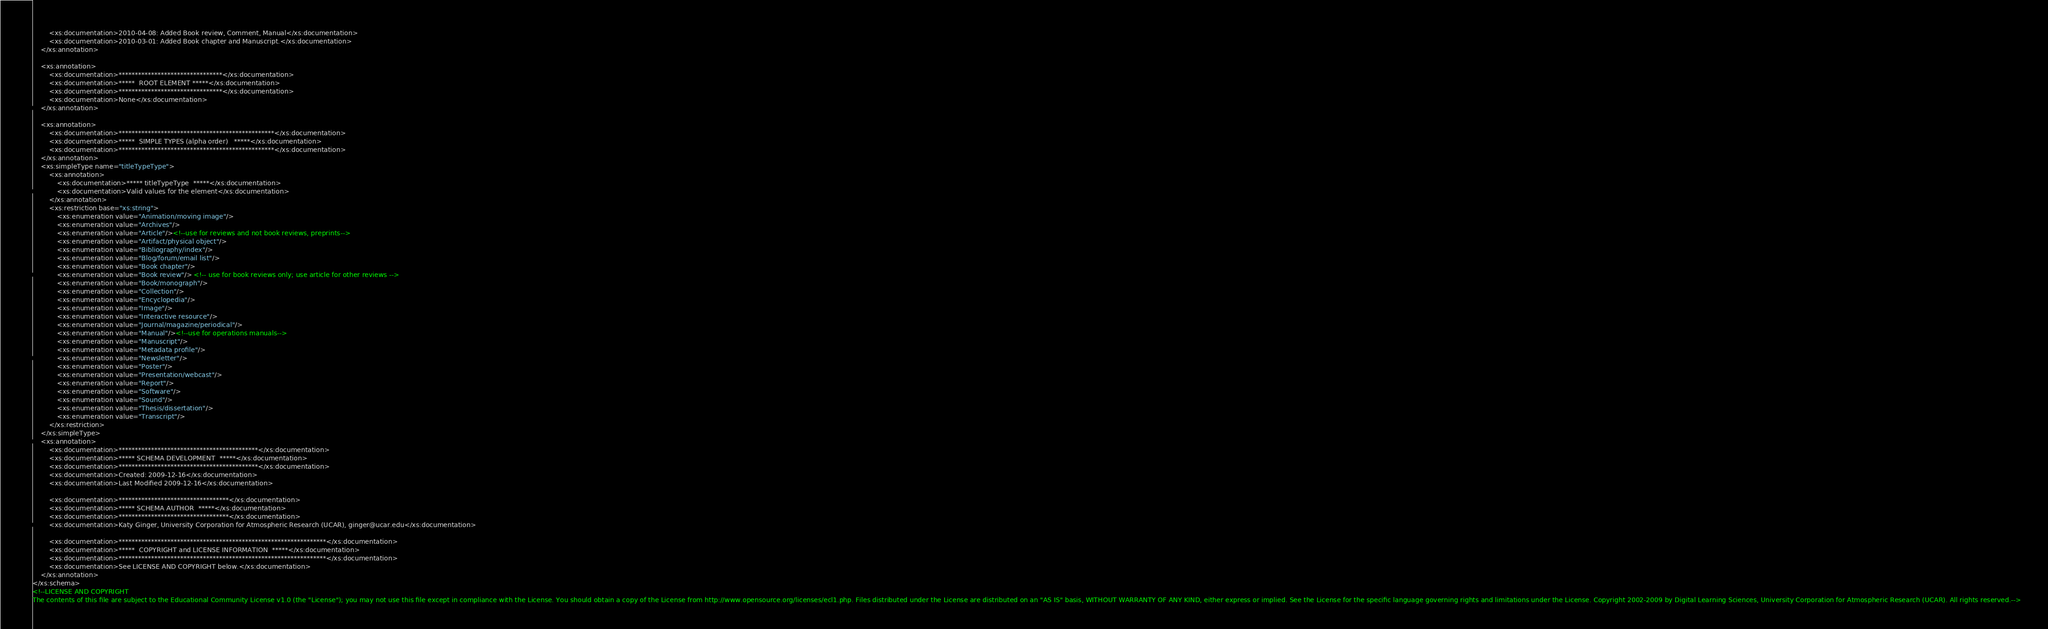Convert code to text. <code><loc_0><loc_0><loc_500><loc_500><_XML_>		<xs:documentation>2010-04-08: Added Book review, Comment, Manual</xs:documentation>
		<xs:documentation>2010-03-01: Added Book chapter and Manuscript.</xs:documentation>
	</xs:annotation>

	<xs:annotation>
		<xs:documentation>********************************</xs:documentation>
		<xs:documentation>*****  ROOT ELEMENT *****</xs:documentation>
		<xs:documentation>********************************</xs:documentation>
		<xs:documentation>None</xs:documentation>
	</xs:annotation>

	<xs:annotation>
		<xs:documentation>************************************************</xs:documentation>
		<xs:documentation>*****  SIMPLE TYPES (alpha order)   *****</xs:documentation>
		<xs:documentation>************************************************</xs:documentation>
	</xs:annotation>
	<xs:simpleType name="titleTypeType">
		<xs:annotation>
			<xs:documentation>***** titleTypeType  *****</xs:documentation>
			<xs:documentation>Valid values for the element</xs:documentation>
		</xs:annotation>
		<xs:restriction base="xs:string">
			<xs:enumeration value="Animation/moving image"/>
			<xs:enumeration value="Archives"/>
			<xs:enumeration value="Article"/><!--use for reviews and not book reviews, preprints-->
			<xs:enumeration value="Artifact/physical object"/>
			<xs:enumeration value="Bibliography/index"/>
			<xs:enumeration value="Blog/forum/email list"/>
			<xs:enumeration value="Book chapter"/>
			<xs:enumeration value="Book review"/> <!-- use for book reviews only; use article for other reviews -->
			<xs:enumeration value="Book/monograph"/>
			<xs:enumeration value="Collection"/>
			<xs:enumeration value="Encyclopedia"/>
			<xs:enumeration value="Image"/>
			<xs:enumeration value="Interactive resource"/>
			<xs:enumeration value="Journal/magazine/periodical"/>
			<xs:enumeration value="Manual"/><!--use for operations manuals-->
			<xs:enumeration value="Manuscript"/>
			<xs:enumeration value="Metadata profile"/>
			<xs:enumeration value="Newsletter"/>
			<xs:enumeration value="Poster"/>
			<xs:enumeration value="Presentation/webcast"/>
			<xs:enumeration value="Report"/>
			<xs:enumeration value="Software"/>
			<xs:enumeration value="Sound"/>
			<xs:enumeration value="Thesis/dissertation"/>
			<xs:enumeration value="Transcript"/>
		</xs:restriction>
	</xs:simpleType>
	<xs:annotation>
		<xs:documentation>*******************************************</xs:documentation>
		<xs:documentation>***** SCHEMA DEVELOPMENT  *****</xs:documentation>
		<xs:documentation>*******************************************</xs:documentation>
		<xs:documentation>Created: 2009-12-16</xs:documentation>
		<xs:documentation>Last Modified 2009-12-16</xs:documentation>

		<xs:documentation>**********************************</xs:documentation>
		<xs:documentation>***** SCHEMA AUTHOR  *****</xs:documentation>
		<xs:documentation>**********************************</xs:documentation>
		<xs:documentation>Katy Ginger, University Corporation for Atmospheric Research (UCAR), ginger@ucar.edu</xs:documentation>

		<xs:documentation>****************************************************************</xs:documentation>
		<xs:documentation>*****  COPYRIGHT and LICENSE INFORMATION  *****</xs:documentation>
		<xs:documentation>****************************************************************</xs:documentation>
		<xs:documentation>See LICENSE AND COPYRIGHT below.</xs:documentation>
	</xs:annotation>
</xs:schema>
<!--LICENSE AND COPYRIGHT
The contents of this file are subject to the Educational Community License v1.0 (the "License"); you may not use this file except in compliance with the License. You should obtain a copy of the License from http://www.opensource.org/licenses/ecl1.php. Files distributed under the License are distributed on an "AS IS" basis, WITHOUT WARRANTY OF ANY KIND, either express or implied. See the License for the specific language governing rights and limitations under the License. Copyright 2002-2009 by Digital Learning Sciences, University Corporation for Atmospheric Research (UCAR). All rights reserved.--></code> 